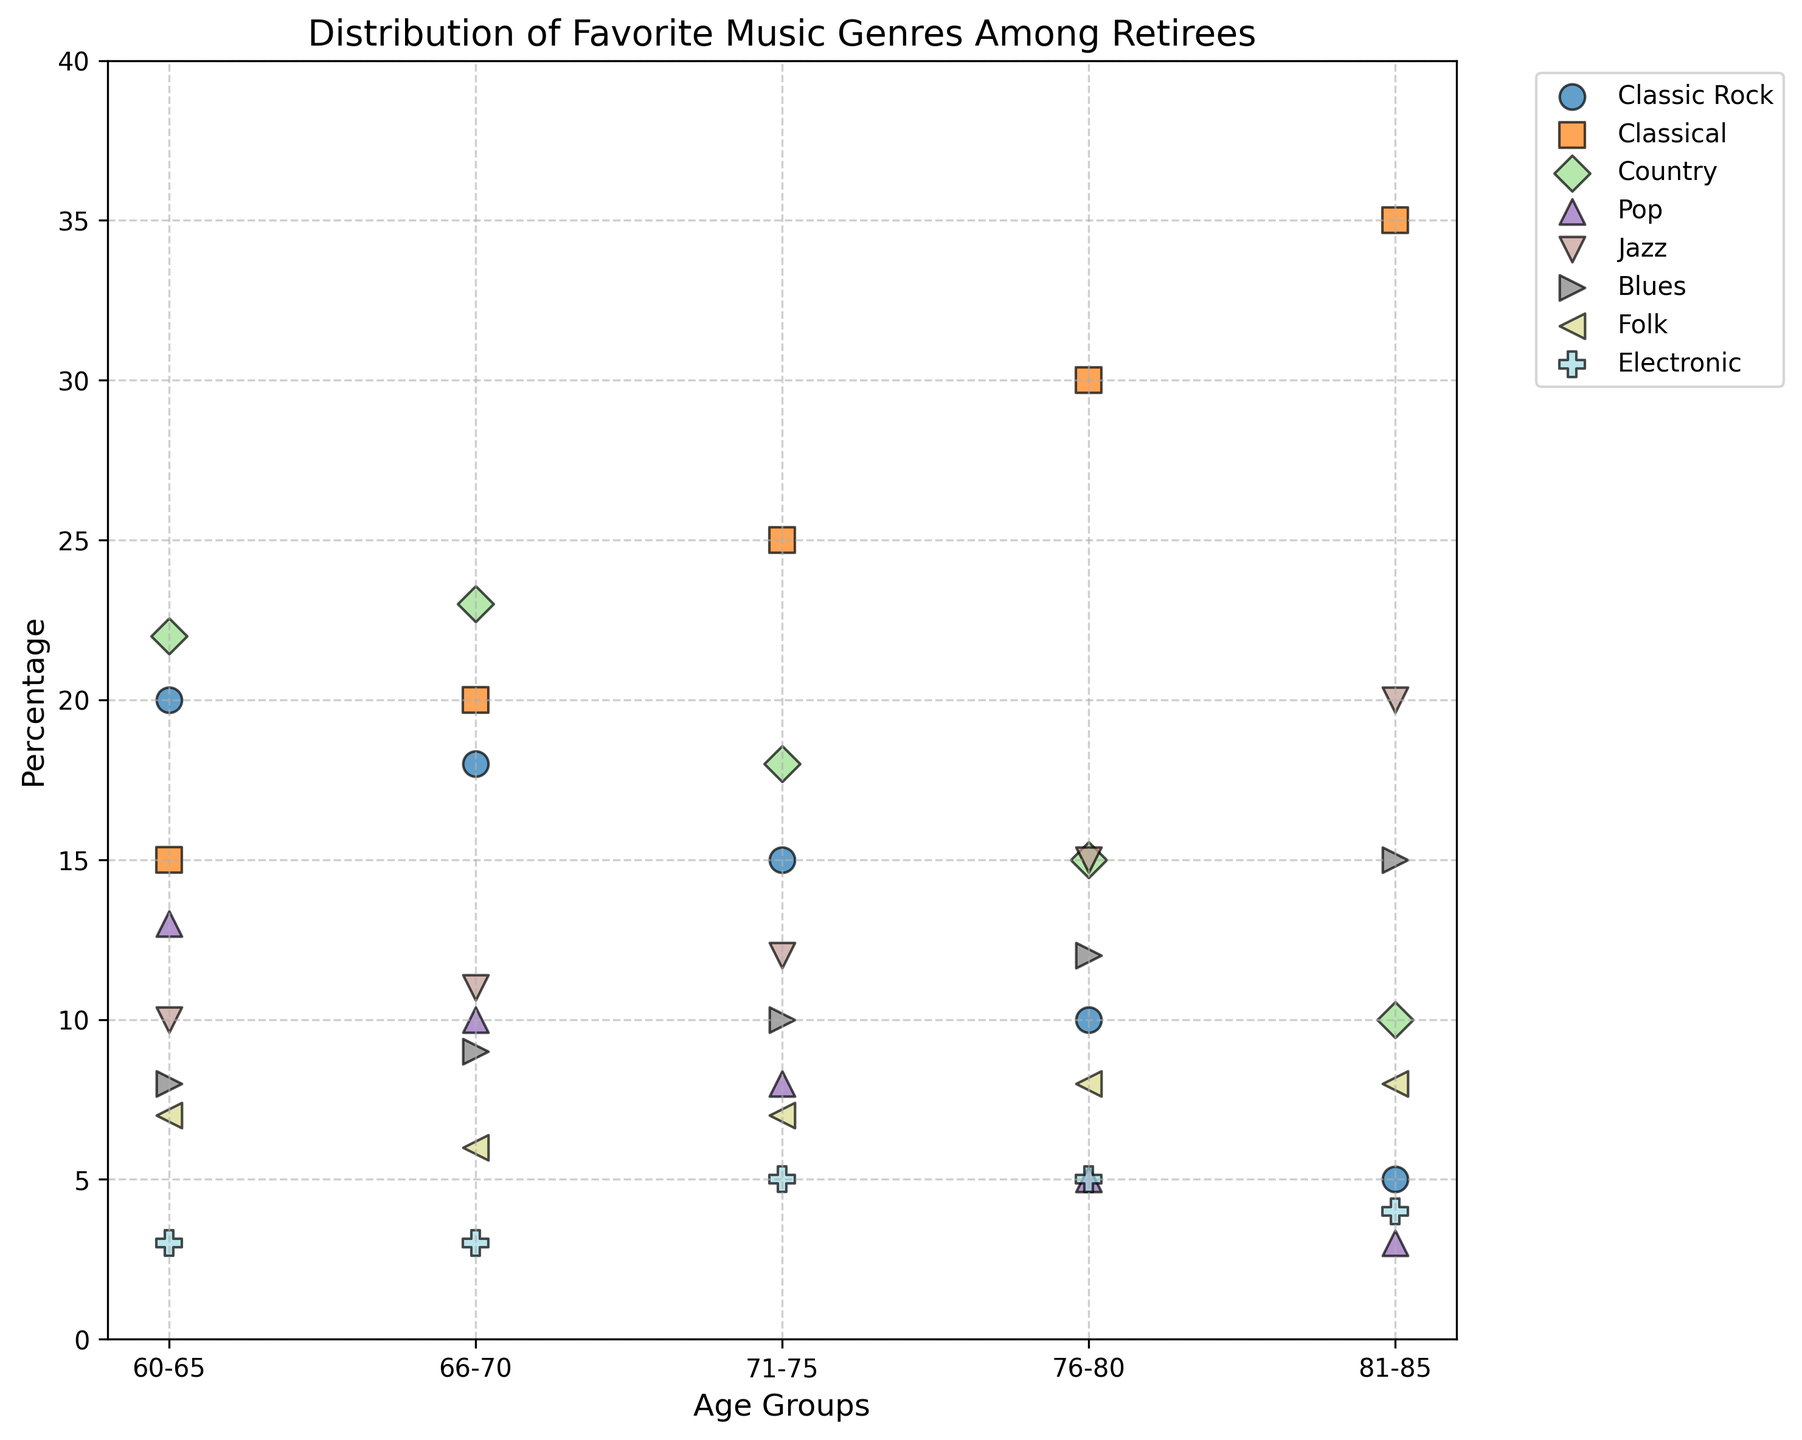What age group has the highest percentage for Classic Rock? Look for the point for Classic Rock in different age groups and observe the y-axis values. The highest point for Classic Rock is in the 60-65 age group with a percentage of 20%.
Answer: 60-65 Which genre has the lowest percentage in the 60-65 age group? Identify the points corresponding to the 60-65 age group and check their percentages. Electronic has the lowest percentage of 3%.
Answer: Electronic What is the total percentage of Classical music preference across all age groups? Add the percentages for Classical music across age groups: 15 (60-65) + 20 (66-70) + 25 (71-75) + 30 (76-80) + 35 (81-85) = 125.
Answer: 125 Are there any genres with the same percentage in the 66-70 and 76-80 age groups? Compare the percentages of genres in the 66-70 and 76-80 age groups. Both Electronic have the same percentage of 3%.
Answer: Yes, Electronic Which genre shows a steady increase in percentage from the 60-65 age group to the 81-85 age group? Observe the trend in percentage for each genre across age groups. Classical music shows a steady increase: 15%, 20%, 25%, 30%, 35%.
Answer: Classical What is the difference in percentage for Jazz between the 60-65 and 81-85 age groups? Subtract the percentage of Jazz in the 60-65 age group from the percentage in the 81-85 age group: 20% - 10% = 10%.
Answer: 10% Which age group shows the highest preference for Country music? Find the highest point for Country music across age groups. The 66-70 age group has the highest preference with 23%.
Answer: 66-70 What is the combined percentage of Pop music preference for the 60-65 and 71-75 age groups? Add the percentages for Pop music in the 60-65 and 71-75 age groups: 13% + 8% = 21%.
Answer: 21% Which genre has the highest percentage in the 81-85 age group? Check the percentages of all genres in the 81-85 age group. Classical has the highest percentage of 35%.
Answer: Classical 